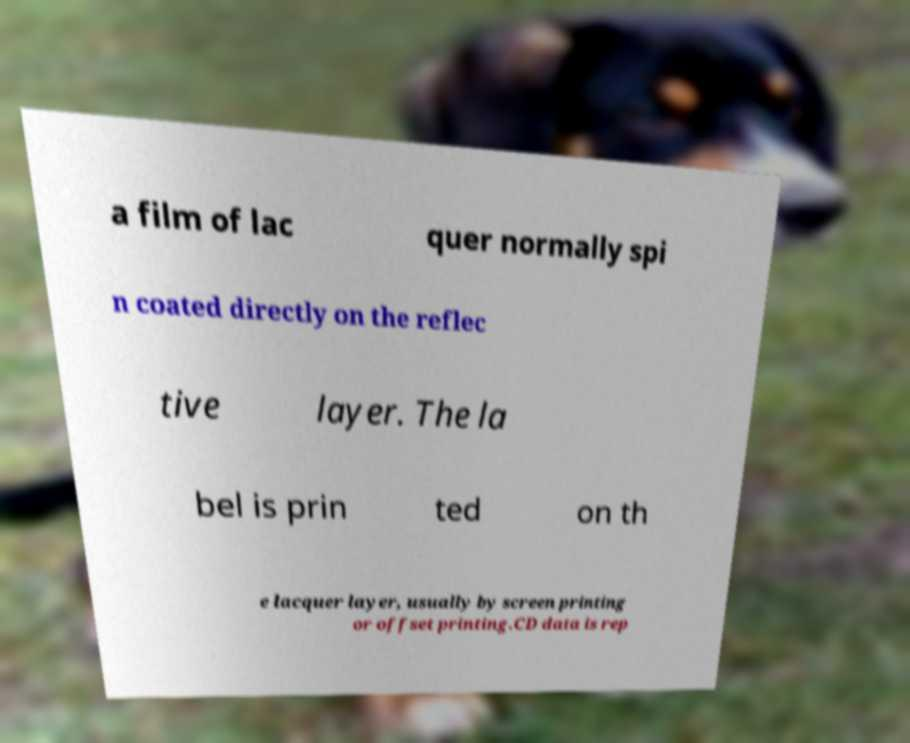Could you extract and type out the text from this image? a film of lac quer normally spi n coated directly on the reflec tive layer. The la bel is prin ted on th e lacquer layer, usually by screen printing or offset printing.CD data is rep 